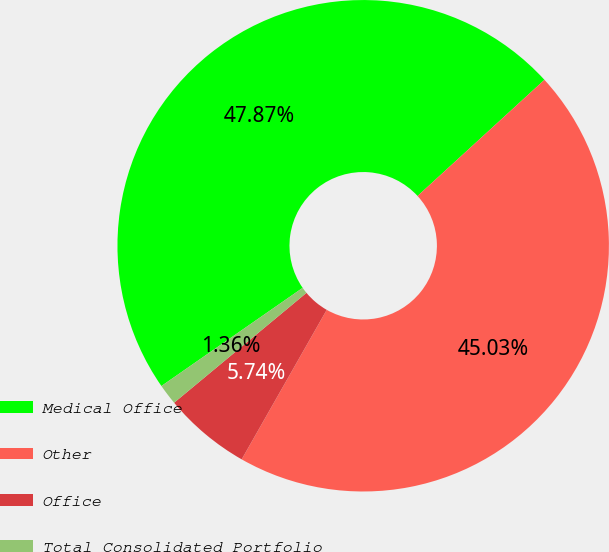Convert chart. <chart><loc_0><loc_0><loc_500><loc_500><pie_chart><fcel>Medical Office<fcel>Other<fcel>Office<fcel>Total Consolidated Portfolio<nl><fcel>47.87%<fcel>45.03%<fcel>5.74%<fcel>1.36%<nl></chart> 